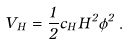Convert formula to latex. <formula><loc_0><loc_0><loc_500><loc_500>V _ { H } = \frac { 1 } { 2 } c _ { H } H ^ { 2 } \phi ^ { 2 } \, .</formula> 